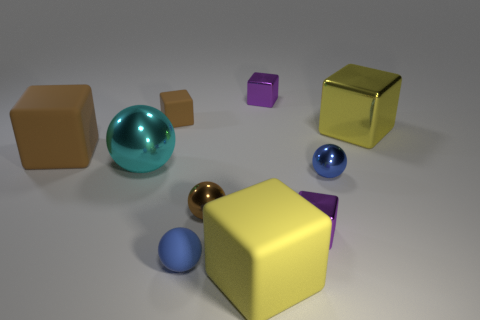Subtract all tiny purple shiny cubes. How many cubes are left? 4 Subtract all purple balls. How many purple blocks are left? 2 Subtract all yellow blocks. How many blocks are left? 4 Subtract all spheres. How many objects are left? 6 Subtract 4 cubes. How many cubes are left? 2 Subtract 0 yellow balls. How many objects are left? 10 Subtract all purple blocks. Subtract all green balls. How many blocks are left? 4 Subtract all large purple balls. Subtract all tiny metallic spheres. How many objects are left? 8 Add 1 tiny balls. How many tiny balls are left? 4 Add 3 large yellow things. How many large yellow things exist? 5 